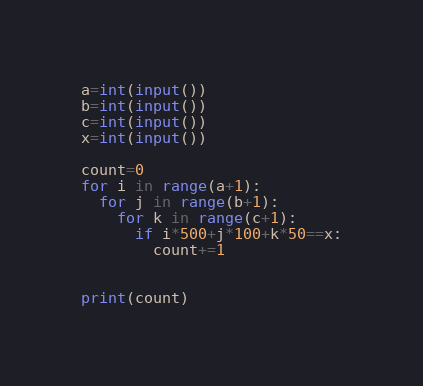Convert code to text. <code><loc_0><loc_0><loc_500><loc_500><_Python_>a=int(input())
b=int(input())
c=int(input())
x=int(input())

count=0
for i in range(a+1):
  for j in range(b+1):
    for k in range(c+1):
      if i*500+j*100+k*50==x:
        count+=1
      
    
print(count)</code> 